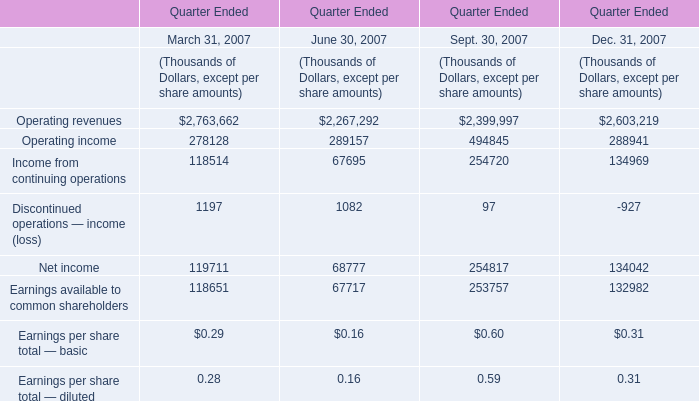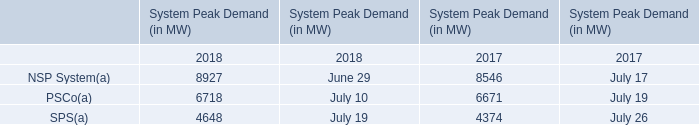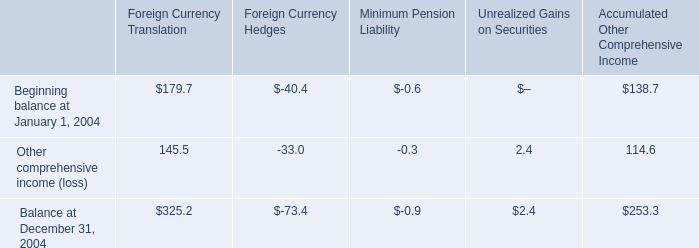In which year is Income from continuing operations positive? 
Answer: March 31, 2007 June 30, 2007 Sept. 30, 2007 Dec. 31, 2007. 